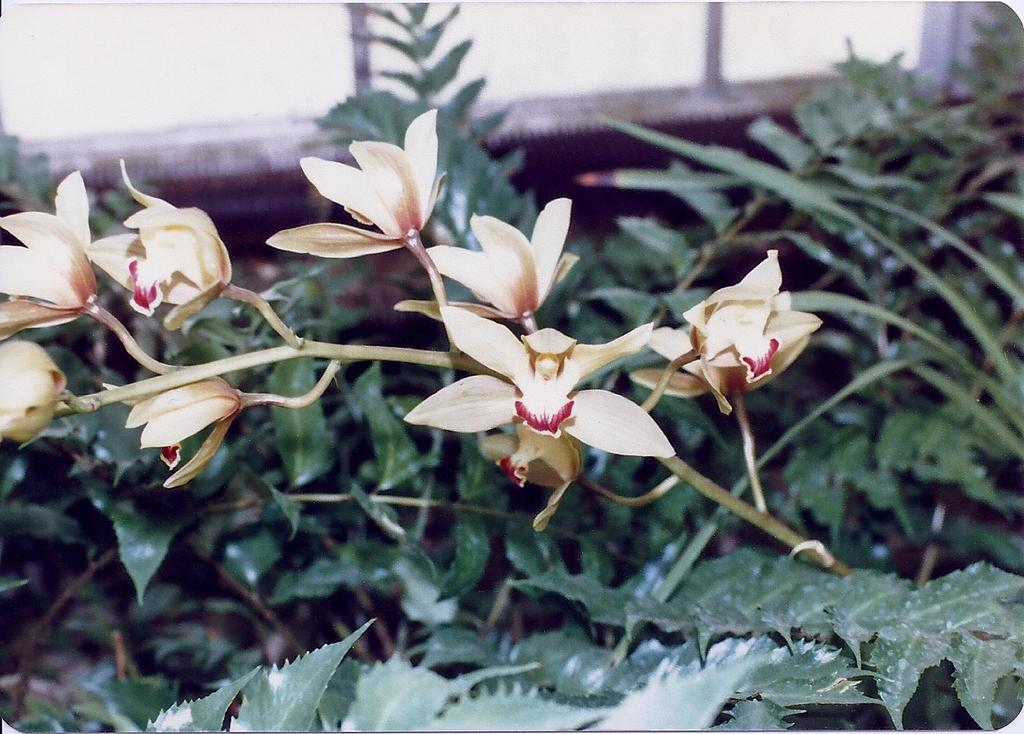What type of living organisms can be seen in the image? Plants and flowers are visible in the image. What is the background of the image? There is a wall in the image. What type of agreement can be seen in the image? There is no agreement visible in the image; it features plants, flowers, and a wall. What type of camp is depicted in the image? There is no camp present in the image; it features plants, flowers, and a wall. 